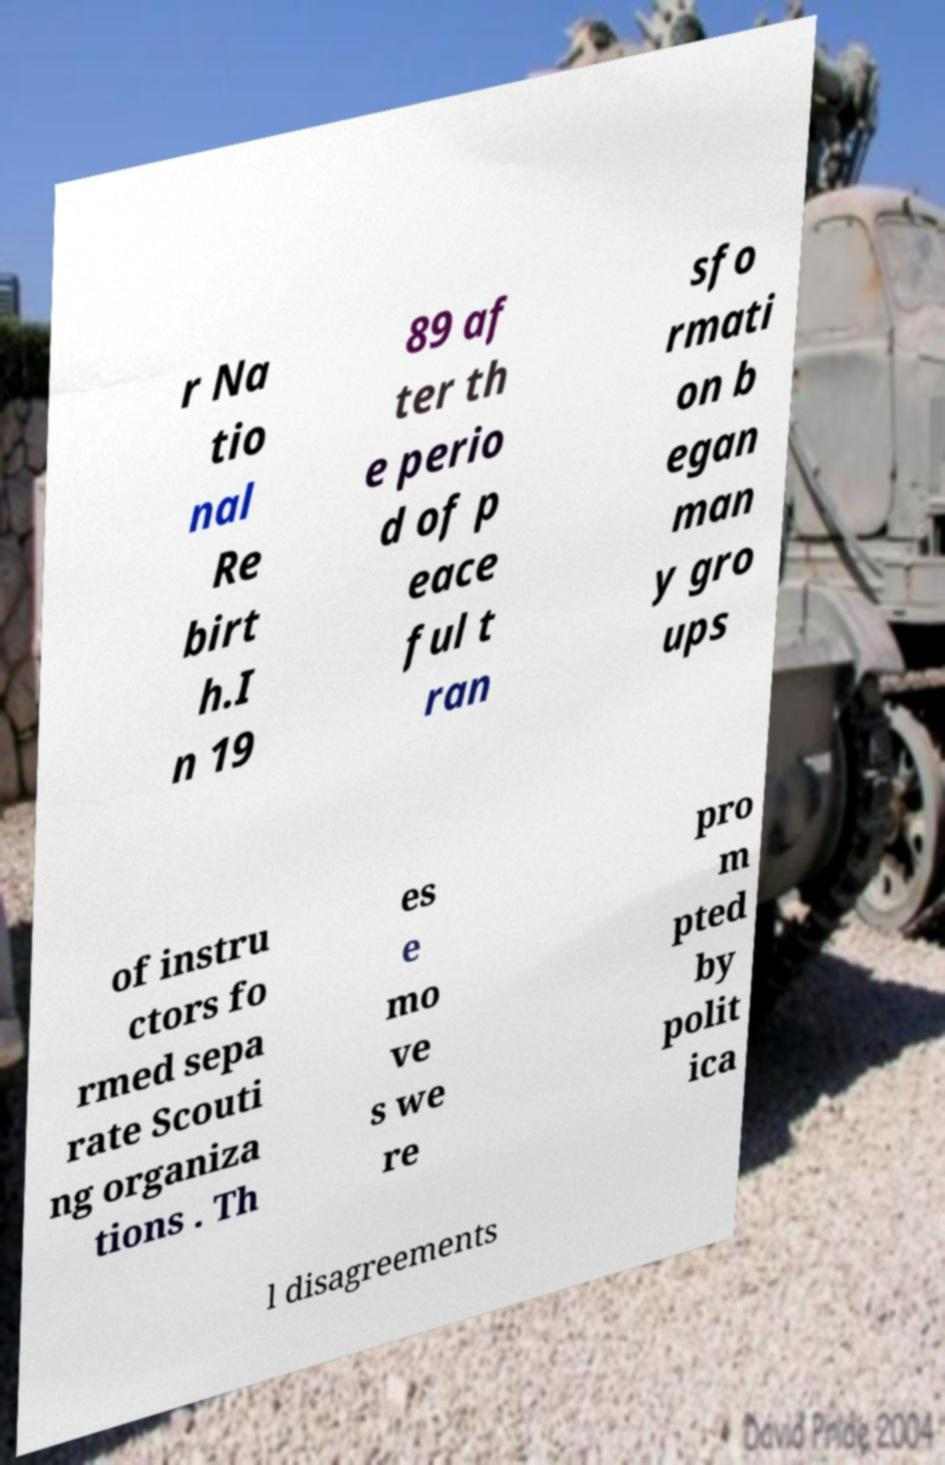What messages or text are displayed in this image? I need them in a readable, typed format. r Na tio nal Re birt h.I n 19 89 af ter th e perio d of p eace ful t ran sfo rmati on b egan man y gro ups of instru ctors fo rmed sepa rate Scouti ng organiza tions . Th es e mo ve s we re pro m pted by polit ica l disagreements 